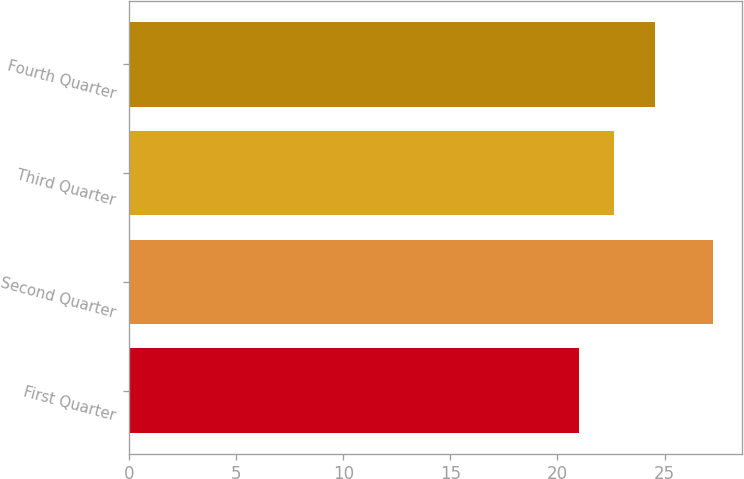<chart> <loc_0><loc_0><loc_500><loc_500><bar_chart><fcel>First Quarter<fcel>Second Quarter<fcel>Third Quarter<fcel>Fourth Quarter<nl><fcel>21.01<fcel>27.24<fcel>22.66<fcel>24.55<nl></chart> 